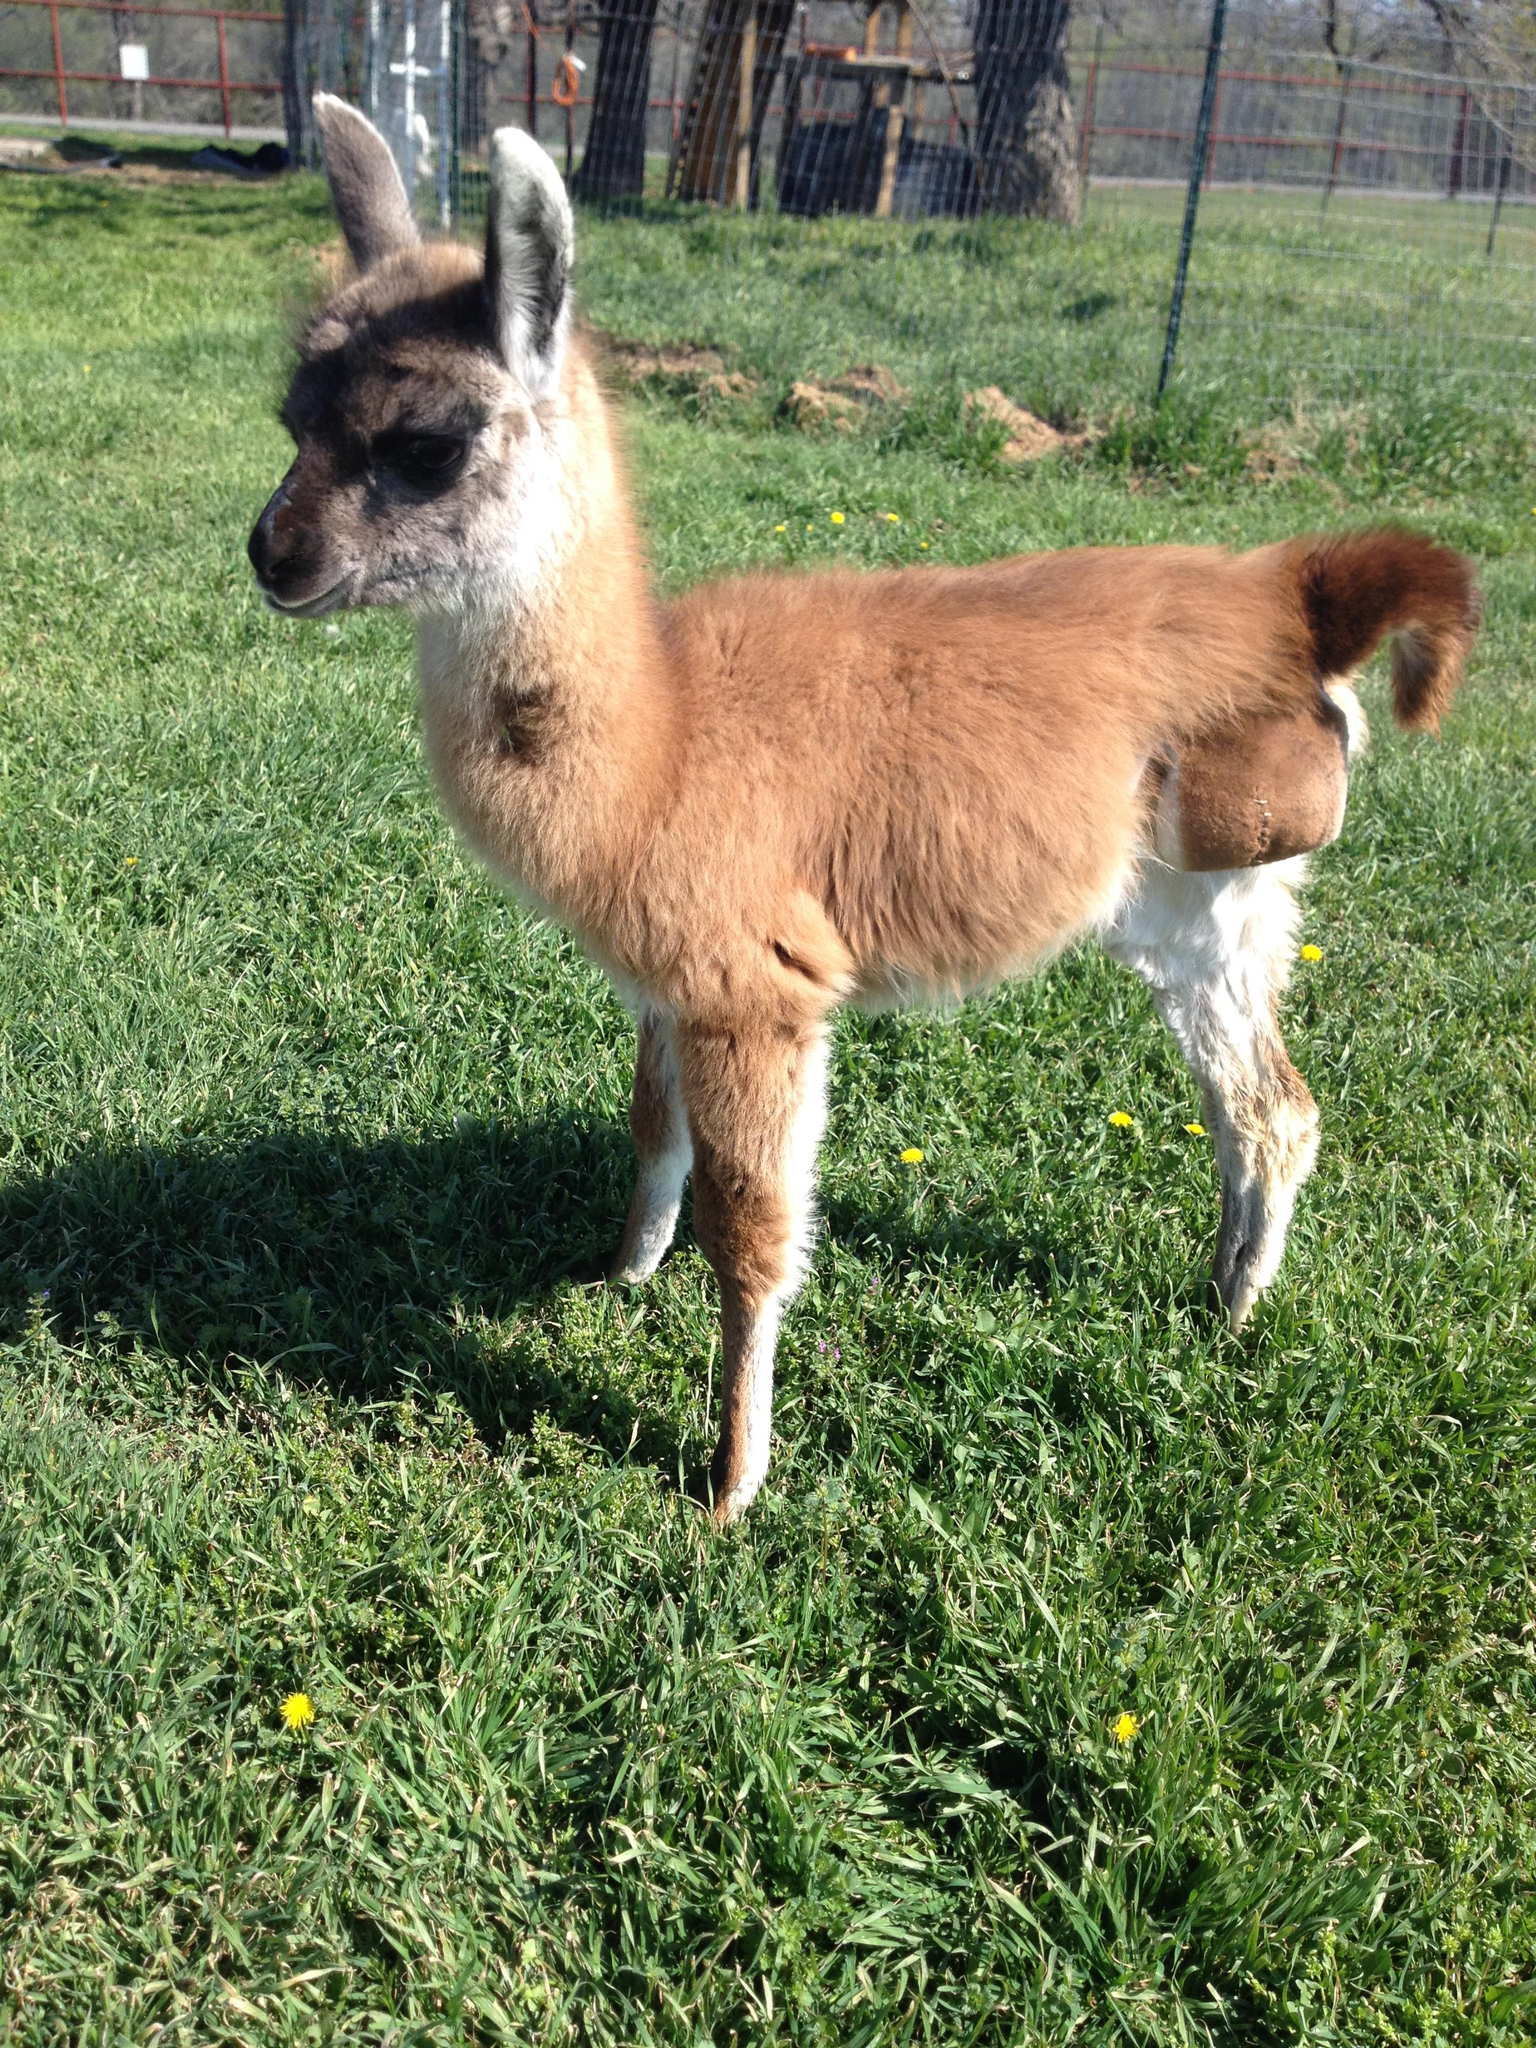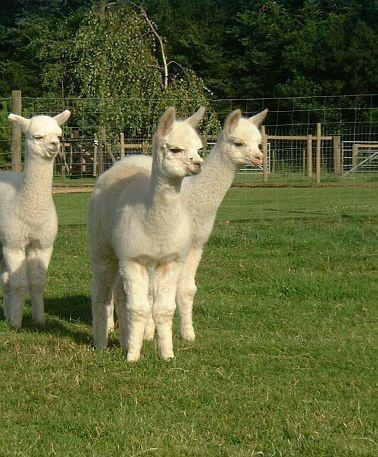The first image is the image on the left, the second image is the image on the right. Analyze the images presented: Is the assertion "The left image contains one standing brown-and-white llama, and the right image contains at least two all white llamas." valid? Answer yes or no. Yes. The first image is the image on the left, the second image is the image on the right. Analyze the images presented: Is the assertion "There are four llamas." valid? Answer yes or no. Yes. 